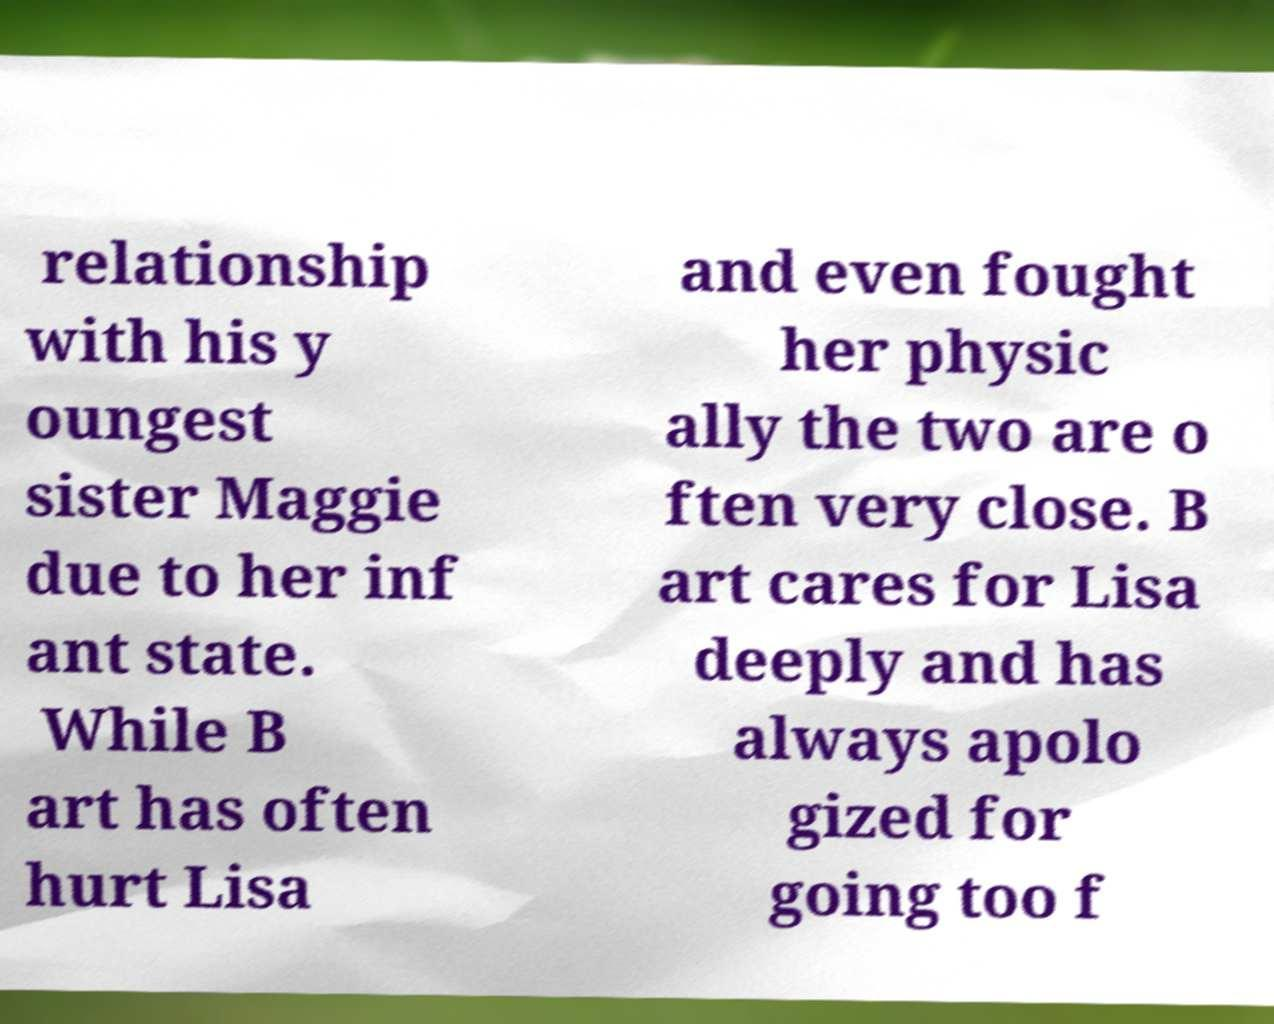For documentation purposes, I need the text within this image transcribed. Could you provide that? relationship with his y oungest sister Maggie due to her inf ant state. While B art has often hurt Lisa and even fought her physic ally the two are o ften very close. B art cares for Lisa deeply and has always apolo gized for going too f 